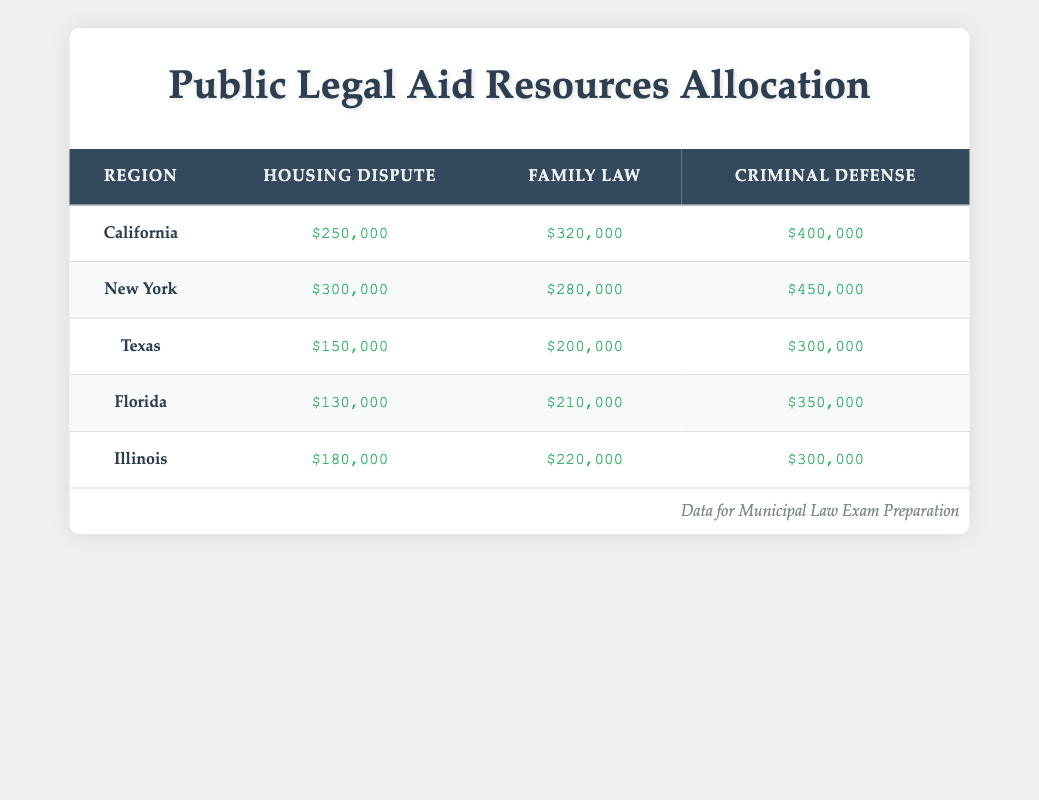What is the total amount allocated for Criminal Defense in California? In the table, the allocated resources for Criminal Defense in California is listed as $400,000. Since we only need this single value, there are no additional calculations or steps required.
Answer: $400,000 Which region received the highest allocation for Family Law? To determine this, we can compare the Family Law figures across all regions. The values are $320,000 for California, $280,000 for New York, $200,000 for Texas, $210,000 for Florida, and $220,000 for Illinois. The highest is clearly $320,000 from California.
Answer: California What is the sum of resources allocated for Housing Disputes across all regions? We take the Housing Dispute amounts from each region: $250,000 (California) + $300,000 (New York) + $150,000 (Texas) + $130,000 (Florida) + $180,000 (Illinois). Adding these gives $1,010,000.
Answer: $1,010,000 Is the allocation for Family Law in Florida greater than that in Texas? The Family Law allocation for Florida is $210,000, and for Texas, it is $200,000. Since $210,000 is greater than $200,000, the answer is yes.
Answer: Yes What is the average allocation for Criminal Defense across all regions? We have the values for Criminal Defense as follows: $400,000 (California), $450,000 (New York), $300,000 (Texas), $350,000 (Florida), and $300,000 (Illinois). First, we sum these amounts: $400,000 + $450,000 + $300,000 + $350,000 + $300,000 = $1,800,000. Next, we divide by the number of regions, which is 5: $1,800,000 / 5 = $360,000.
Answer: $360,000 Which legal issue received the least amount of allocated resources in Texas? Reviewing the amounts allocated for Texas, we see $150,000 for Housing Dispute, $200,000 for Family Law, and $300,000 for Criminal Defense. The least amount is $150,000 for Housing Dispute.
Answer: Housing Dispute What region has a greater allocation for Housing Disputes than Florida? The Housing Dispute amounts are $250,000 (California), $300,000 (New York), $150,000 (Texas), $130,000 (Florida), and $180,000 (Illinois). Comparing these values to Florida's $130,000, both California and New York have greater allocations: $250,000 and $300,000, respectively.
Answer: California and New York What is the difference in allocated resources for Criminal Defense between New York and Illinois? The allocated resources for Criminal Defense in New York is $450,000 and in Illinois it is $300,000. To find the difference, we subtract: $450,000 - $300,000 = $150,000.
Answer: $150,000 Which type of legal issue received the highest allocation in New York? In New York, the allocations are $300,000 for Housing Dispute, $280,000 for Family Law, and $450,000 for Criminal Defense. Clearly, the highest is $450,000 for Criminal Defense.
Answer: Criminal Defense 